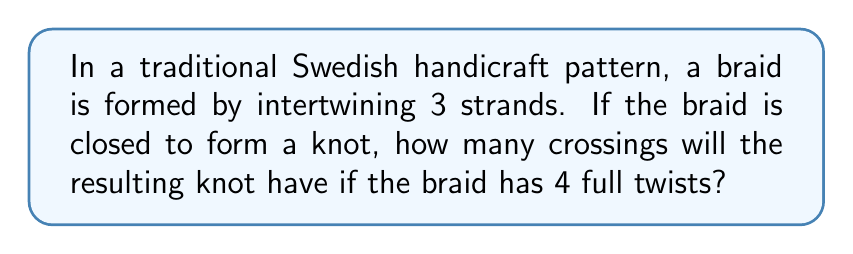Could you help me with this problem? Let's approach this step-by-step:

1. In a 3-strand braid, each full twist creates 3 crossings.

2. We can represent this mathematically as:
   $$\text{Crossings per twist} = 3$$

3. We are given that there are 4 full twists in the braid. So, we multiply:
   $$\text{Total crossings in braid} = 4 \times 3 = 12$$

4. When we close the braid to form a knot, we don't add any additional crossings.

5. Therefore, the number of crossings in the resulting knot is equal to the number of crossings in the braid:
   $$\text{Crossings in knot} = 12$$

This type of knot formed from a closed braid is known as a torus knot, specifically a $(3,4)$ torus knot, where 3 represents the number of strands and 4 represents the number of full twists.
Answer: 12 crossings 